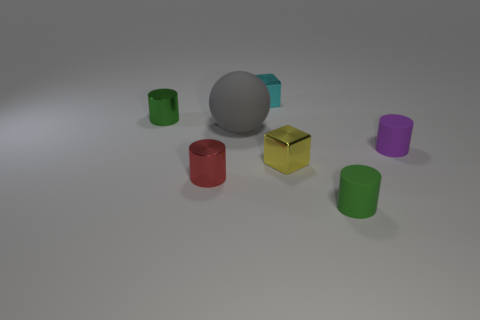Subtract all yellow spheres. How many green cylinders are left? 2 Subtract all red cylinders. How many cylinders are left? 3 Subtract all balls. How many objects are left? 6 Subtract all yellow cylinders. Subtract all brown cubes. How many cylinders are left? 4 Add 3 red metallic cylinders. How many objects exist? 10 Add 6 purple cylinders. How many purple cylinders exist? 7 Subtract 1 gray balls. How many objects are left? 6 Subtract all tiny green cylinders. Subtract all cyan things. How many objects are left? 4 Add 6 tiny green cylinders. How many tiny green cylinders are left? 8 